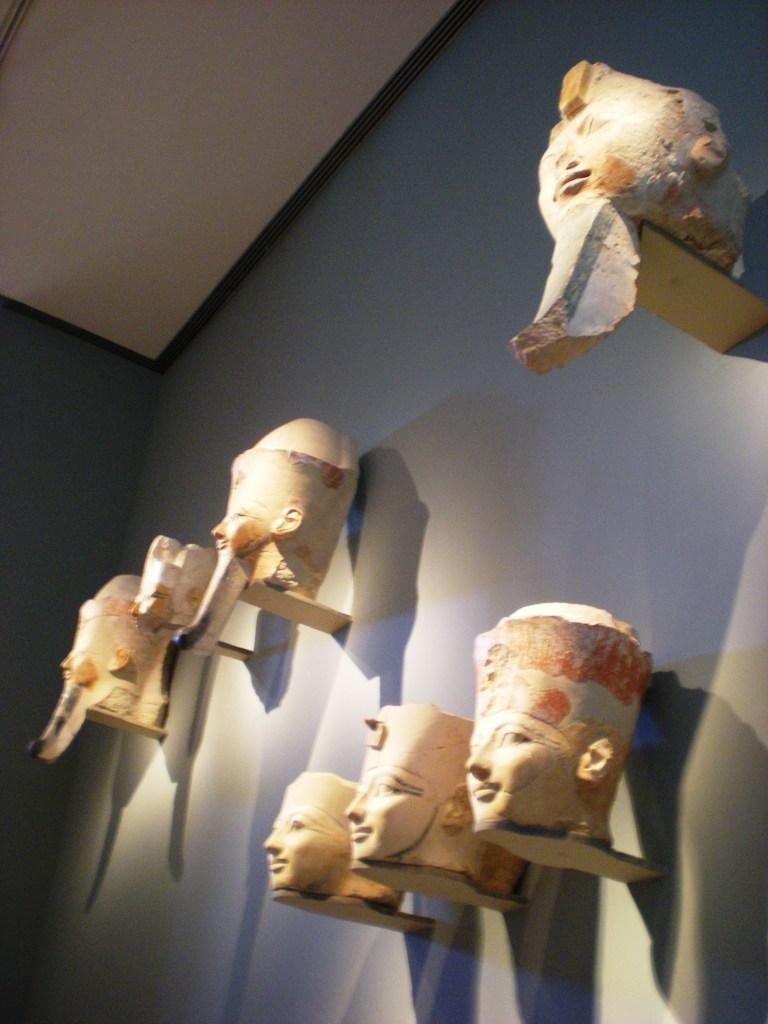What is the main subject of the image? The main subject of the image is head sculptures. Where are the head sculptures located in the image? The head sculptures are in the middle of the image. What type of pocket is being used by the head sculptures in the image? There are no pockets present in the image, as it features head sculptures without any clothing or accessories. 